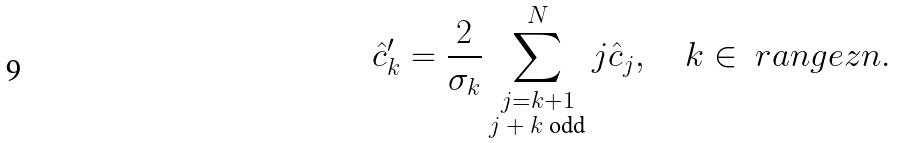Convert formula to latex. <formula><loc_0><loc_0><loc_500><loc_500>\hat { c } ^ { \prime } _ { k } = \frac { 2 } { \sigma _ { k } } \sum _ { \substack { j = k + 1 \\ \text {$j+k$ odd} } } ^ { N } j \hat { c } _ { j } , \quad k \in \ r a n g e z { n } .</formula> 